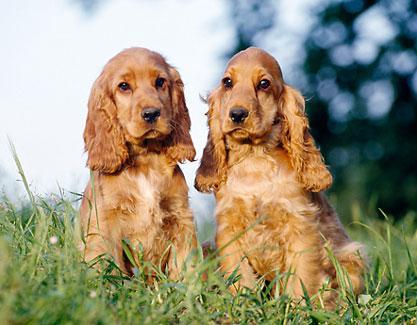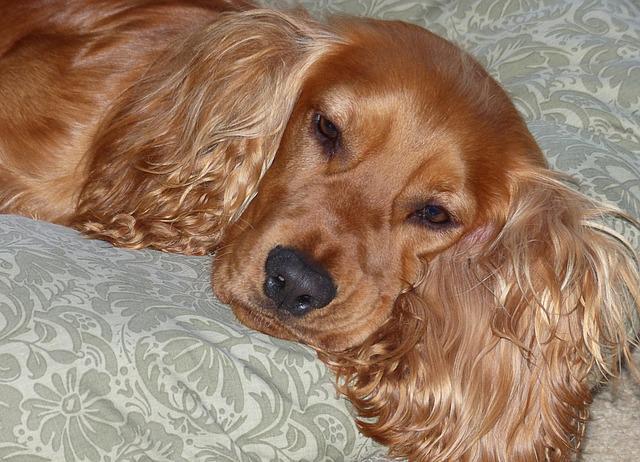The first image is the image on the left, the second image is the image on the right. Evaluate the accuracy of this statement regarding the images: "At least one of the dogs is laying down.". Is it true? Answer yes or no. Yes. The first image is the image on the left, the second image is the image on the right. Evaluate the accuracy of this statement regarding the images: "One curly eared dog is facing right.". Is it true? Answer yes or no. No. 